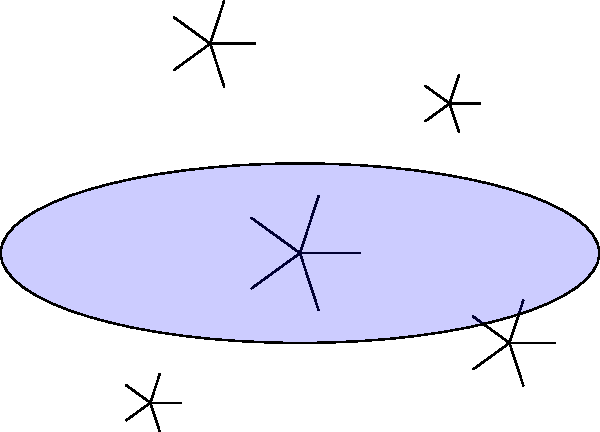During a night watch, you observe this celestial object through the ship's telescope. What type of nebula or galaxy is this most likely to be? To identify this celestial object, let's analyze its key features:

1. Overall shape: The object has an elliptical shape, which is common in many galaxies and nebulae.

2. Central concentration: There's a bright central region, indicated by the larger star at the center.

3. Spiral structure: A distinct red spiral pattern is visible, emanating from the center outwards.

4. Scattered stars: Several smaller stars are visible throughout the object.

5. Blue haze: A faint blue elliptical haze surrounds the entire structure.

Given these characteristics, we can deduce:

- The spiral structure is a key identifier, ruling out elliptical galaxies and most types of nebulae.
- The presence of visible stars within the object suggests it's a galaxy rather than a nebula.
- The combination of a spiral structure and an overall elliptical shape is characteristic of a specific type of galaxy.

Considering all these factors, this object is most likely a spiral galaxy viewed at an angle. The red spiral represents the galaxy's arms, the central star is the galactic core, and the blue haze represents the galaxy's outer regions containing younger, bluer stars.
Answer: Spiral galaxy 